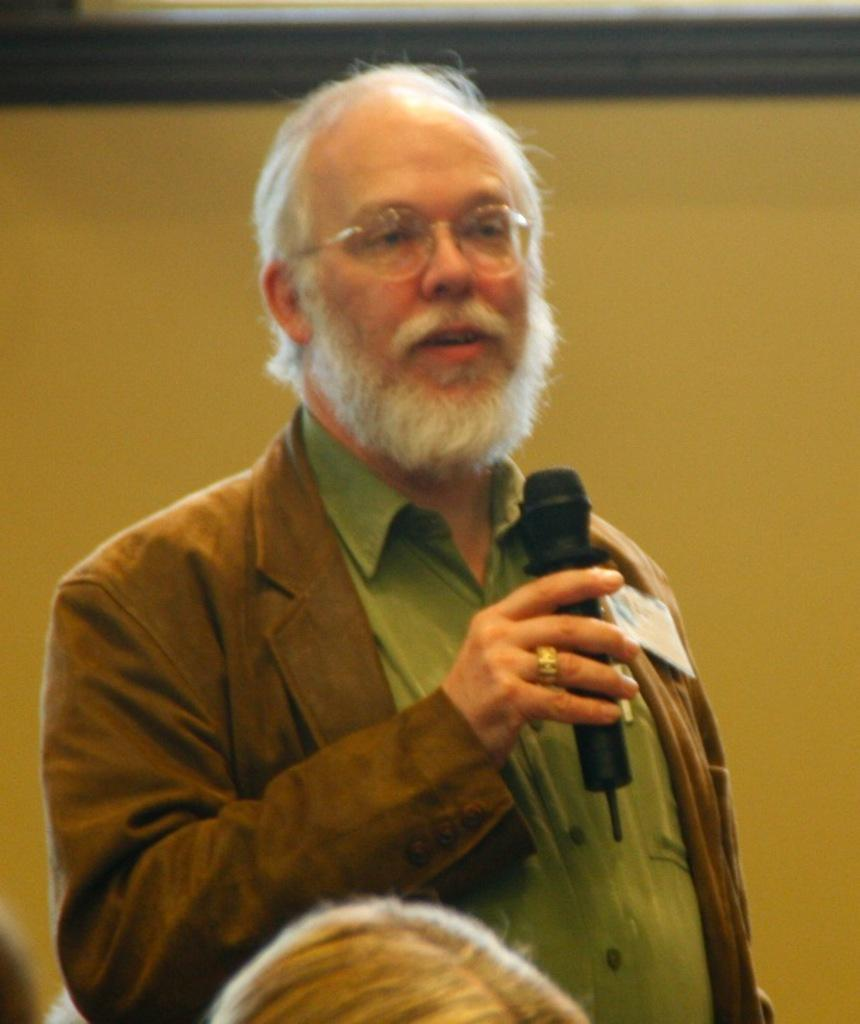Who is the main subject in the image? There is an old man in the center of the image. What is the old man holding in his hand? The old man is holding a mic in his hand. Can you describe the other person in the image? There appears to be another person at the bottom side of the image. How many bills of money can be seen in the old man's pocket in the image? There is no mention of money or pockets in the image, so it cannot be determined how many bills might be present. 